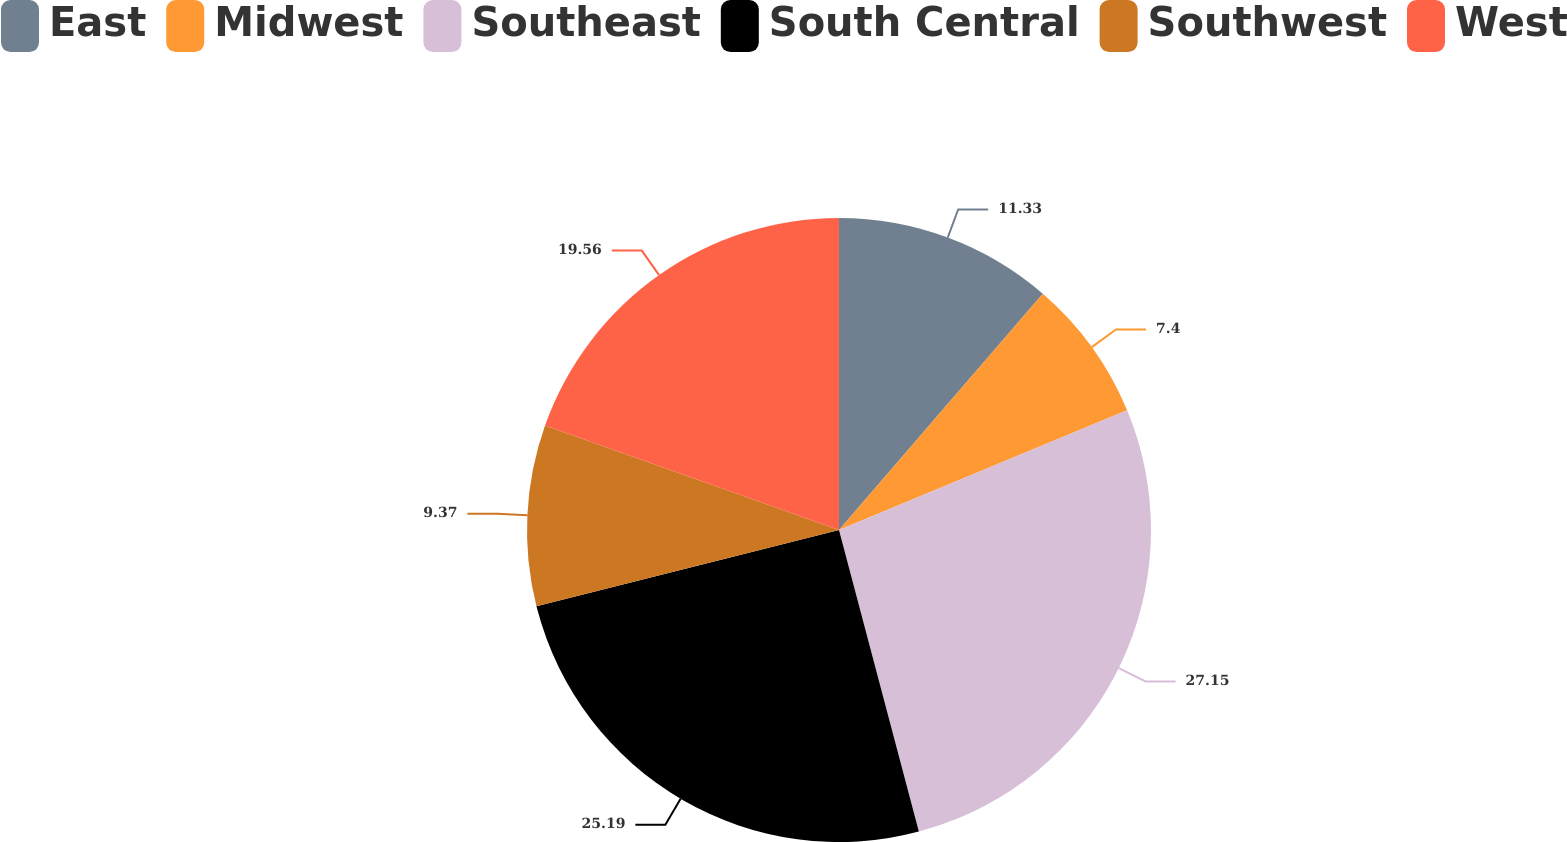Convert chart to OTSL. <chart><loc_0><loc_0><loc_500><loc_500><pie_chart><fcel>East<fcel>Midwest<fcel>Southeast<fcel>South Central<fcel>Southwest<fcel>West<nl><fcel>11.33%<fcel>7.4%<fcel>27.15%<fcel>25.19%<fcel>9.37%<fcel>19.56%<nl></chart> 